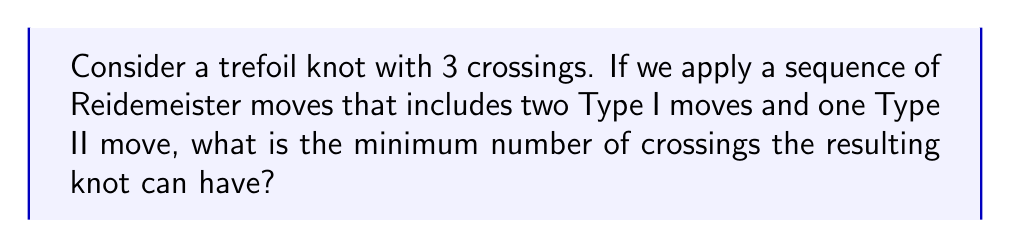Can you answer this question? Let's approach this step-by-step:

1) The trefoil knot is the simplest non-trivial knot, with a crossing number of 3.

2) Reidemeister moves are local changes to a knot diagram that do not change the knot type. There are three types:
   - Type I: Adds or removes a twist in the strand
   - Type II: Adds or removes two crossings
   - Type III: Slides a strand from one side of a crossing to the other

3) In this problem, we're applying two Type I moves and one Type II move.

4) Type I moves can either increase or decrease the number of crossings by 1:
   $$\Delta crossings_{TypeI} = \pm 1$$

5) Type II moves can either increase or decrease the number of crossings by 2:
   $$\Delta crossings_{TypeII} = \pm 2$$

6) To minimize the number of crossings, we want to use these moves to reduce crossings as much as possible:
   - Two Type I moves reducing crossings: $-1 -1 = -2$
   - One Type II move reducing crossings: $-2$

7) The total reduction in crossings is:
   $$\Delta crossings_{total} = -2 - 2 = -4$$

8) However, the trefoil knot is non-trivial, meaning it cannot be reduced to a simple loop (unknot). The crossing number of the trefoil is an invariant under Reidemeister moves.

9) Therefore, the minimum number of crossings after these moves is still 3, the same as the original trefoil knot.
Answer: 3 